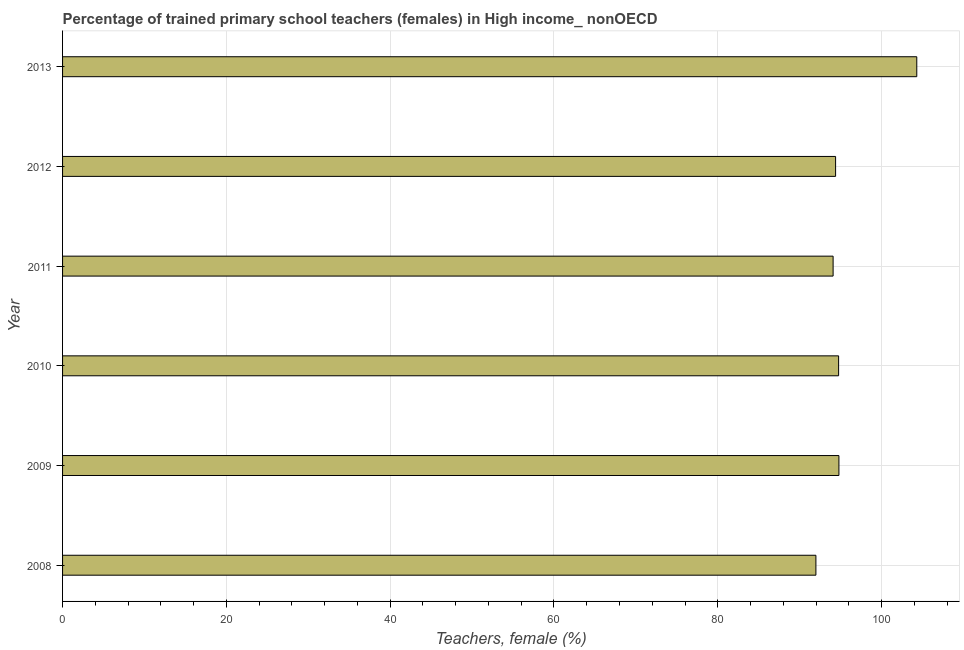Does the graph contain grids?
Your answer should be compact. Yes. What is the title of the graph?
Your answer should be compact. Percentage of trained primary school teachers (females) in High income_ nonOECD. What is the label or title of the X-axis?
Provide a short and direct response. Teachers, female (%). What is the percentage of trained female teachers in 2009?
Provide a short and direct response. 94.79. Across all years, what is the maximum percentage of trained female teachers?
Make the answer very short. 104.3. Across all years, what is the minimum percentage of trained female teachers?
Make the answer very short. 91.99. In which year was the percentage of trained female teachers maximum?
Your answer should be compact. 2013. In which year was the percentage of trained female teachers minimum?
Give a very brief answer. 2008. What is the sum of the percentage of trained female teachers?
Your answer should be compact. 574.31. What is the difference between the percentage of trained female teachers in 2011 and 2013?
Provide a short and direct response. -10.22. What is the average percentage of trained female teachers per year?
Make the answer very short. 95.72. What is the median percentage of trained female teachers?
Give a very brief answer. 94.57. In how many years, is the percentage of trained female teachers greater than 24 %?
Give a very brief answer. 6. Is the percentage of trained female teachers in 2011 less than that in 2012?
Offer a very short reply. Yes. What is the difference between the highest and the second highest percentage of trained female teachers?
Provide a short and direct response. 9.51. What is the difference between the highest and the lowest percentage of trained female teachers?
Ensure brevity in your answer.  12.32. How many bars are there?
Your answer should be very brief. 6. Are all the bars in the graph horizontal?
Offer a very short reply. Yes. How many years are there in the graph?
Offer a terse response. 6. What is the difference between two consecutive major ticks on the X-axis?
Give a very brief answer. 20. What is the Teachers, female (%) of 2008?
Your answer should be very brief. 91.99. What is the Teachers, female (%) of 2009?
Ensure brevity in your answer.  94.79. What is the Teachers, female (%) in 2010?
Your answer should be compact. 94.76. What is the Teachers, female (%) in 2011?
Ensure brevity in your answer.  94.08. What is the Teachers, female (%) in 2012?
Provide a short and direct response. 94.39. What is the Teachers, female (%) in 2013?
Ensure brevity in your answer.  104.3. What is the difference between the Teachers, female (%) in 2008 and 2009?
Your response must be concise. -2.81. What is the difference between the Teachers, female (%) in 2008 and 2010?
Your answer should be very brief. -2.77. What is the difference between the Teachers, female (%) in 2008 and 2011?
Your answer should be very brief. -2.1. What is the difference between the Teachers, female (%) in 2008 and 2012?
Your answer should be very brief. -2.4. What is the difference between the Teachers, female (%) in 2008 and 2013?
Offer a very short reply. -12.32. What is the difference between the Teachers, female (%) in 2009 and 2010?
Give a very brief answer. 0.04. What is the difference between the Teachers, female (%) in 2009 and 2011?
Your answer should be very brief. 0.71. What is the difference between the Teachers, female (%) in 2009 and 2012?
Keep it short and to the point. 0.41. What is the difference between the Teachers, female (%) in 2009 and 2013?
Provide a succinct answer. -9.51. What is the difference between the Teachers, female (%) in 2010 and 2011?
Offer a very short reply. 0.67. What is the difference between the Teachers, female (%) in 2010 and 2012?
Ensure brevity in your answer.  0.37. What is the difference between the Teachers, female (%) in 2010 and 2013?
Offer a terse response. -9.54. What is the difference between the Teachers, female (%) in 2011 and 2012?
Give a very brief answer. -0.3. What is the difference between the Teachers, female (%) in 2011 and 2013?
Make the answer very short. -10.22. What is the difference between the Teachers, female (%) in 2012 and 2013?
Offer a terse response. -9.91. What is the ratio of the Teachers, female (%) in 2008 to that in 2010?
Your answer should be compact. 0.97. What is the ratio of the Teachers, female (%) in 2008 to that in 2011?
Your response must be concise. 0.98. What is the ratio of the Teachers, female (%) in 2008 to that in 2013?
Keep it short and to the point. 0.88. What is the ratio of the Teachers, female (%) in 2009 to that in 2012?
Keep it short and to the point. 1. What is the ratio of the Teachers, female (%) in 2009 to that in 2013?
Provide a short and direct response. 0.91. What is the ratio of the Teachers, female (%) in 2010 to that in 2012?
Offer a very short reply. 1. What is the ratio of the Teachers, female (%) in 2010 to that in 2013?
Make the answer very short. 0.91. What is the ratio of the Teachers, female (%) in 2011 to that in 2012?
Your answer should be compact. 1. What is the ratio of the Teachers, female (%) in 2011 to that in 2013?
Provide a succinct answer. 0.9. What is the ratio of the Teachers, female (%) in 2012 to that in 2013?
Offer a very short reply. 0.91. 